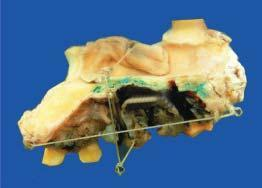s an elevated blackish ulcerated area with irregular outlines?
Answer the question using a single word or phrase. Yes 